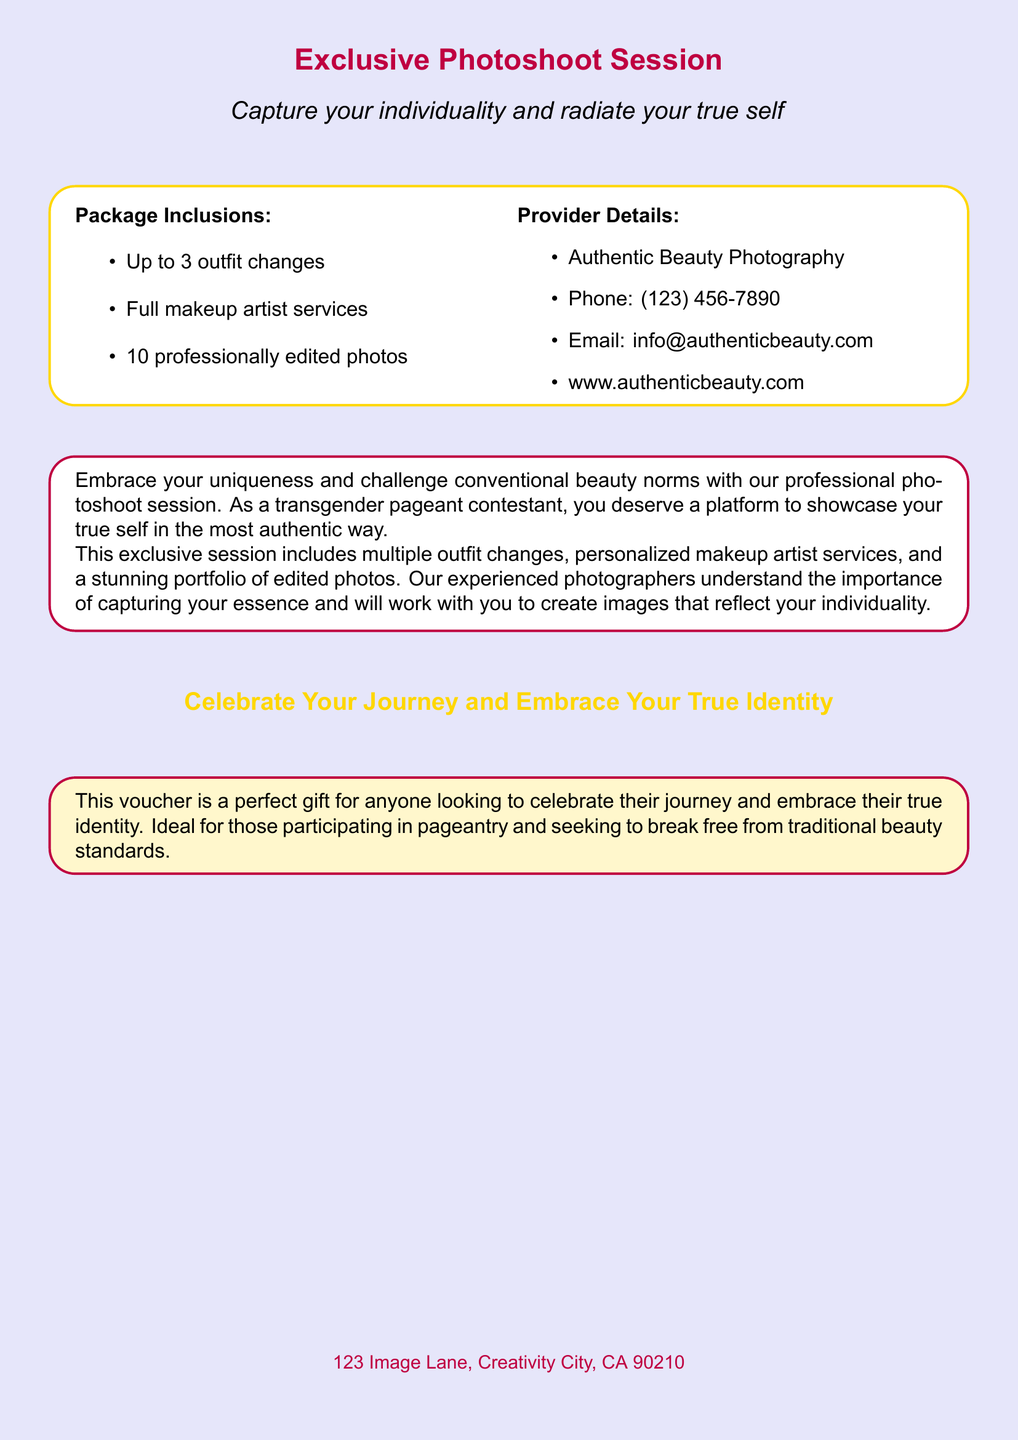What is the primary service offered? The document primarily offers a professional photoshoot session focused on individuality and self-expression.
Answer: Exclusive Photoshoot Session How many outfit changes are included? The document states that the package allows for up to three outfit changes during the photoshoot.
Answer: Up to 3 outfit changes What type of professional service is included besides photography? The document mentions full makeup artist services as part of the photoshoot package.
Answer: Full makeup artist services How many edited photos will participants receive? The document indicates that participants will receive ten professionally edited photos from the session.
Answer: 10 professionally edited photos What is the contact phone number for the provider? The document provides a specific phone number for contacting the provider of the photoshoot service.
Answer: (123) 456-7890 Which company offers this photoshoot session? The document names the company offering the photoshoot session, which is related to authentic beauty photography services.
Answer: Authentic Beauty Photography What is the intent behind this photoshoot session? The document emphasizes the goal of embracing uniqueness and challenging conventional beauty norms.
Answer: Embrace your uniqueness For whom is this voucher particularly ideal? The document suggests that the voucher is particularly fitting for individuals participating in pageantry.
Answer: Pageantry participants 